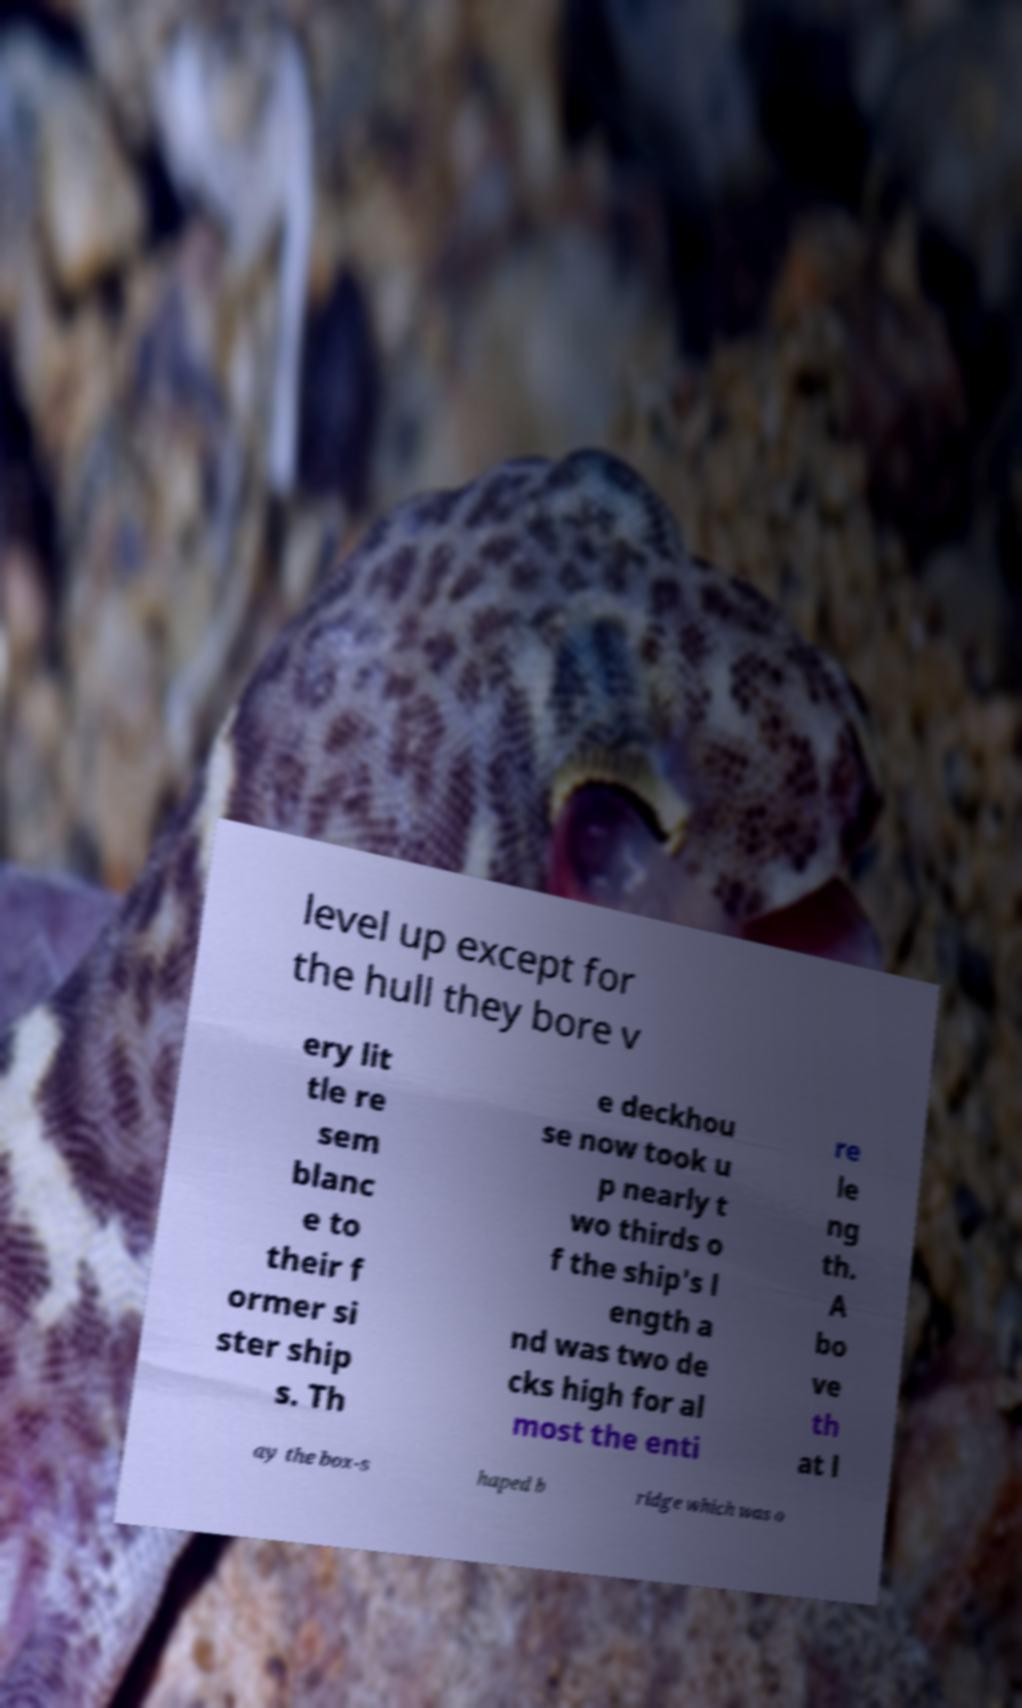Please identify and transcribe the text found in this image. level up except for the hull they bore v ery lit tle re sem blanc e to their f ormer si ster ship s. Th e deckhou se now took u p nearly t wo thirds o f the ship's l ength a nd was two de cks high for al most the enti re le ng th. A bo ve th at l ay the box-s haped b ridge which was o 